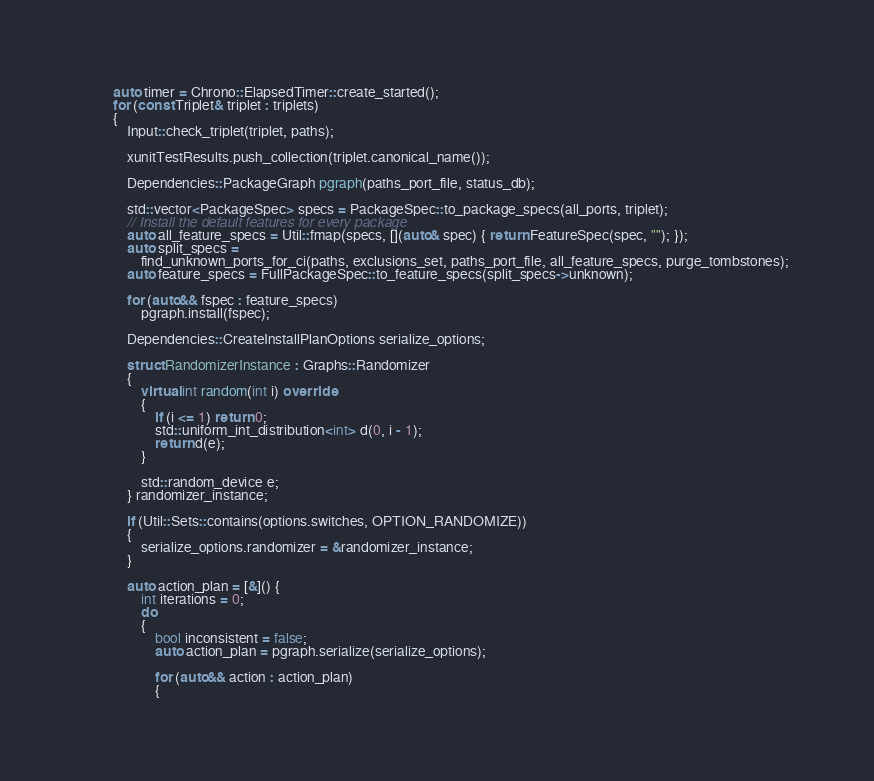Convert code to text. <code><loc_0><loc_0><loc_500><loc_500><_C++_>        auto timer = Chrono::ElapsedTimer::create_started();
        for (const Triplet& triplet : triplets)
        {
            Input::check_triplet(triplet, paths);

            xunitTestResults.push_collection(triplet.canonical_name());

            Dependencies::PackageGraph pgraph(paths_port_file, status_db);

            std::vector<PackageSpec> specs = PackageSpec::to_package_specs(all_ports, triplet);
            // Install the default features for every package
            auto all_feature_specs = Util::fmap(specs, [](auto& spec) { return FeatureSpec(spec, ""); });
            auto split_specs =
                find_unknown_ports_for_ci(paths, exclusions_set, paths_port_file, all_feature_specs, purge_tombstones);
            auto feature_specs = FullPackageSpec::to_feature_specs(split_specs->unknown);

            for (auto&& fspec : feature_specs)
                pgraph.install(fspec);

            Dependencies::CreateInstallPlanOptions serialize_options;

            struct RandomizerInstance : Graphs::Randomizer
            {
                virtual int random(int i) override
                {
                    if (i <= 1) return 0;
                    std::uniform_int_distribution<int> d(0, i - 1);
                    return d(e);
                }

                std::random_device e;
            } randomizer_instance;

            if (Util::Sets::contains(options.switches, OPTION_RANDOMIZE))
            {
                serialize_options.randomizer = &randomizer_instance;
            }

            auto action_plan = [&]() {
                int iterations = 0;
                do
                {
                    bool inconsistent = false;
                    auto action_plan = pgraph.serialize(serialize_options);

                    for (auto&& action : action_plan)
                    {</code> 